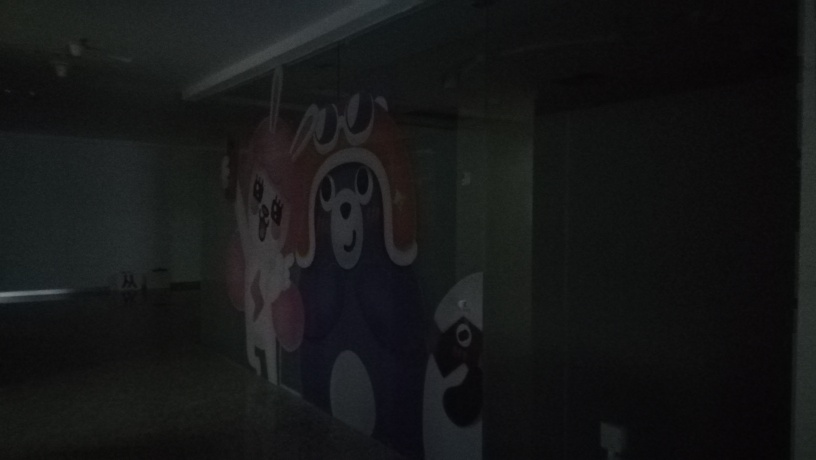Is the image clear? The image is somewhat dark and lacks clear visibility, which may affect the details that can be seen. Improving the lighting could significantly enhance the clarity of the image. 